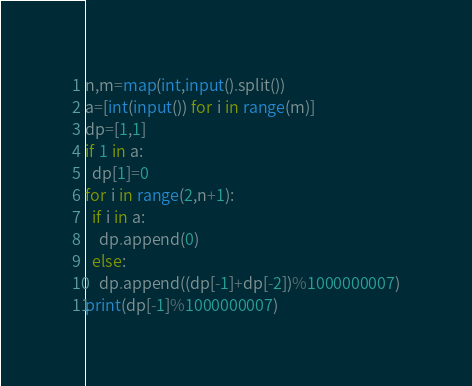Convert code to text. <code><loc_0><loc_0><loc_500><loc_500><_Python_>n,m=map(int,input().split())
a=[int(input()) for i in range(m)]
dp=[1,1]
if 1 in a:
  dp[1]=0
for i in range(2,n+1):
  if i in a:
    dp.append(0)
  else:
    dp.append((dp[-1]+dp[-2])%1000000007)
print(dp[-1]%1000000007)</code> 